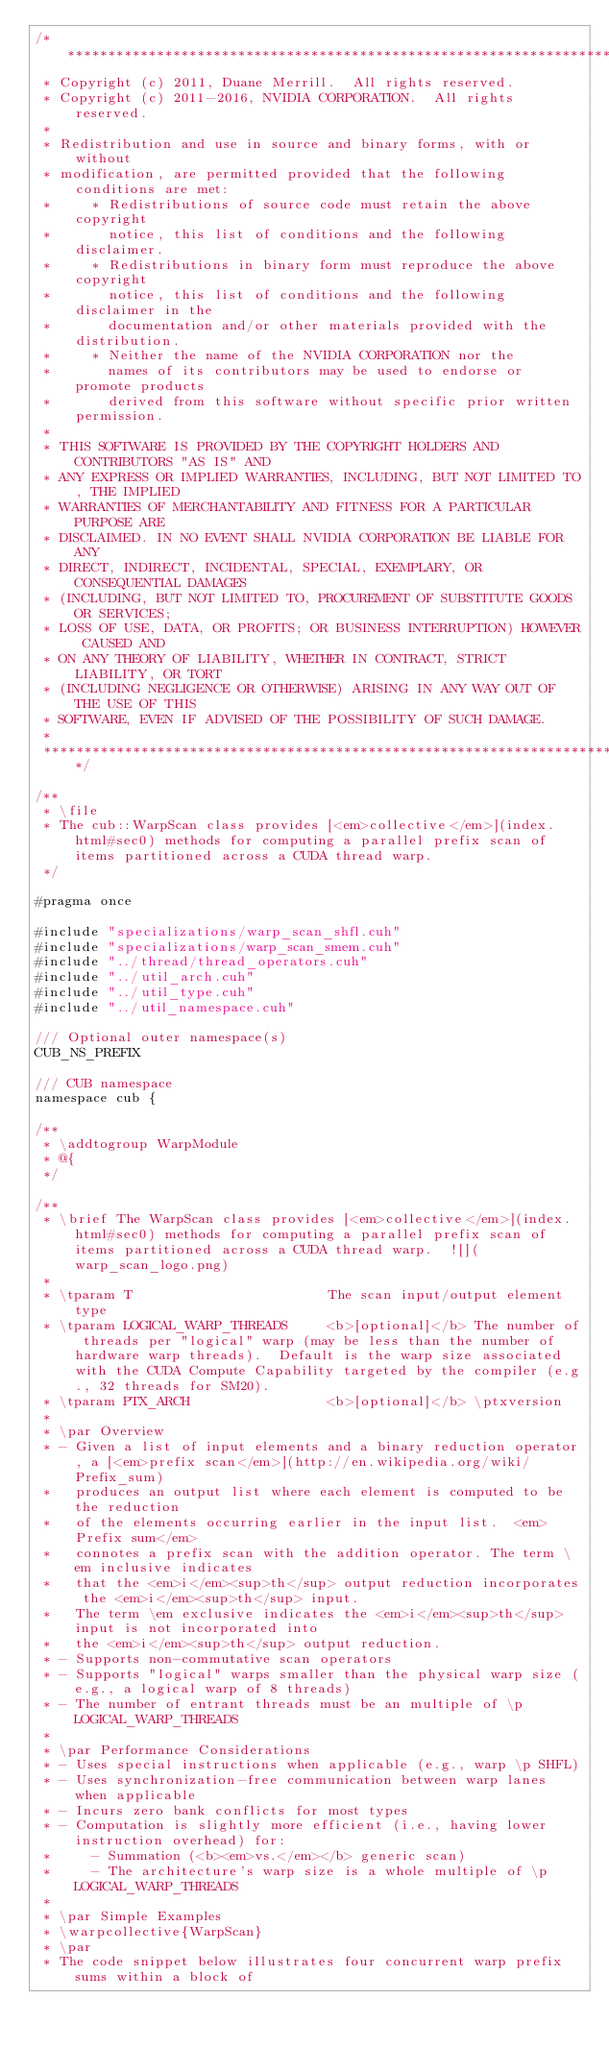<code> <loc_0><loc_0><loc_500><loc_500><_Cuda_>/******************************************************************************
 * Copyright (c) 2011, Duane Merrill.  All rights reserved.
 * Copyright (c) 2011-2016, NVIDIA CORPORATION.  All rights reserved.
 * 
 * Redistribution and use in source and binary forms, with or without
 * modification, are permitted provided that the following conditions are met:
 *     * Redistributions of source code must retain the above copyright
 *       notice, this list of conditions and the following disclaimer.
 *     * Redistributions in binary form must reproduce the above copyright
 *       notice, this list of conditions and the following disclaimer in the
 *       documentation and/or other materials provided with the distribution.
 *     * Neither the name of the NVIDIA CORPORATION nor the
 *       names of its contributors may be used to endorse or promote products
 *       derived from this software without specific prior written permission.
 * 
 * THIS SOFTWARE IS PROVIDED BY THE COPYRIGHT HOLDERS AND CONTRIBUTORS "AS IS" AND
 * ANY EXPRESS OR IMPLIED WARRANTIES, INCLUDING, BUT NOT LIMITED TO, THE IMPLIED
 * WARRANTIES OF MERCHANTABILITY AND FITNESS FOR A PARTICULAR PURPOSE ARE
 * DISCLAIMED. IN NO EVENT SHALL NVIDIA CORPORATION BE LIABLE FOR ANY
 * DIRECT, INDIRECT, INCIDENTAL, SPECIAL, EXEMPLARY, OR CONSEQUENTIAL DAMAGES
 * (INCLUDING, BUT NOT LIMITED TO, PROCUREMENT OF SUBSTITUTE GOODS OR SERVICES;
 * LOSS OF USE, DATA, OR PROFITS; OR BUSINESS INTERRUPTION) HOWEVER CAUSED AND
 * ON ANY THEORY OF LIABILITY, WHETHER IN CONTRACT, STRICT LIABILITY, OR TORT
 * (INCLUDING NEGLIGENCE OR OTHERWISE) ARISING IN ANY WAY OUT OF THE USE OF THIS
 * SOFTWARE, EVEN IF ADVISED OF THE POSSIBILITY OF SUCH DAMAGE.
 *
 ******************************************************************************/

/**
 * \file
 * The cub::WarpScan class provides [<em>collective</em>](index.html#sec0) methods for computing a parallel prefix scan of items partitioned across a CUDA thread warp.
 */

#pragma once

#include "specializations/warp_scan_shfl.cuh"
#include "specializations/warp_scan_smem.cuh"
#include "../thread/thread_operators.cuh"
#include "../util_arch.cuh"
#include "../util_type.cuh"
#include "../util_namespace.cuh"

/// Optional outer namespace(s)
CUB_NS_PREFIX

/// CUB namespace
namespace cub {

/**
 * \addtogroup WarpModule
 * @{
 */

/**
 * \brief The WarpScan class provides [<em>collective</em>](index.html#sec0) methods for computing a parallel prefix scan of items partitioned across a CUDA thread warp.  ![](warp_scan_logo.png)
 *
 * \tparam T                        The scan input/output element type
 * \tparam LOGICAL_WARP_THREADS     <b>[optional]</b> The number of threads per "logical" warp (may be less than the number of hardware warp threads).  Default is the warp size associated with the CUDA Compute Capability targeted by the compiler (e.g., 32 threads for SM20).
 * \tparam PTX_ARCH                 <b>[optional]</b> \ptxversion
 *
 * \par Overview
 * - Given a list of input elements and a binary reduction operator, a [<em>prefix scan</em>](http://en.wikipedia.org/wiki/Prefix_sum)
 *   produces an output list where each element is computed to be the reduction
 *   of the elements occurring earlier in the input list.  <em>Prefix sum</em>
 *   connotes a prefix scan with the addition operator. The term \em inclusive indicates
 *   that the <em>i</em><sup>th</sup> output reduction incorporates the <em>i</em><sup>th</sup> input.
 *   The term \em exclusive indicates the <em>i</em><sup>th</sup> input is not incorporated into
 *   the <em>i</em><sup>th</sup> output reduction.
 * - Supports non-commutative scan operators
 * - Supports "logical" warps smaller than the physical warp size (e.g., a logical warp of 8 threads)
 * - The number of entrant threads must be an multiple of \p LOGICAL_WARP_THREADS
 *
 * \par Performance Considerations
 * - Uses special instructions when applicable (e.g., warp \p SHFL)
 * - Uses synchronization-free communication between warp lanes when applicable
 * - Incurs zero bank conflicts for most types
 * - Computation is slightly more efficient (i.e., having lower instruction overhead) for:
 *     - Summation (<b><em>vs.</em></b> generic scan)
 *     - The architecture's warp size is a whole multiple of \p LOGICAL_WARP_THREADS
 *
 * \par Simple Examples
 * \warpcollective{WarpScan}
 * \par
 * The code snippet below illustrates four concurrent warp prefix sums within a block of</code> 